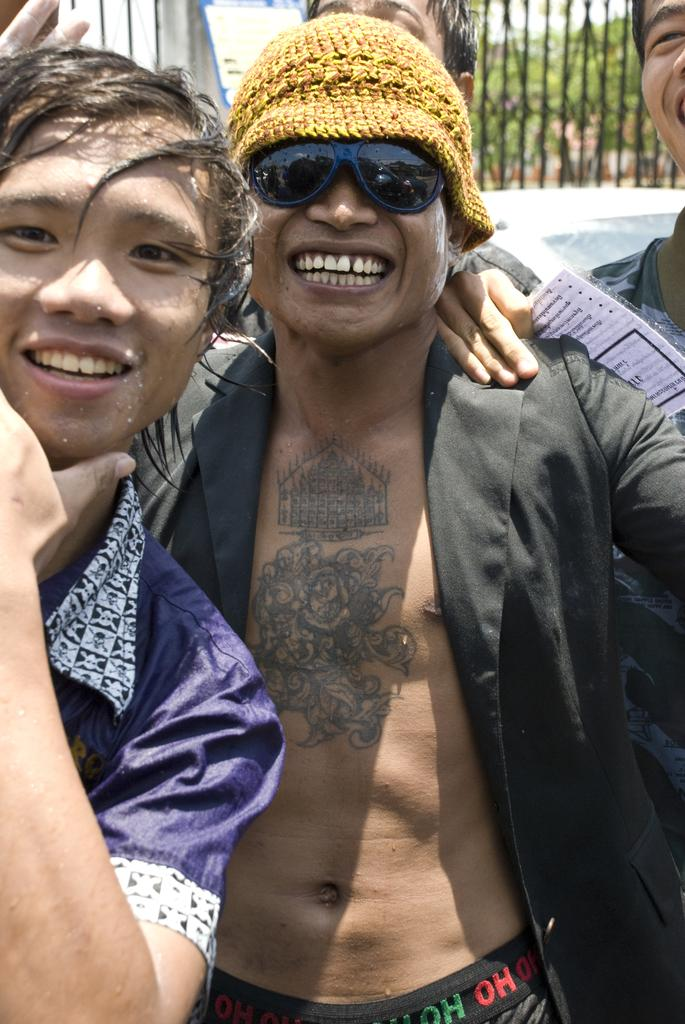What is happening in the image involving the people? There are people standing in the image, and two of them are smiling. Can you describe the background of the image? There is an iron grill in the background of the image. What type of cow can be seen grazing in the background of the image? There is no cow present in the image; it only features people standing and an iron grill in the background. How much butter is visible on the smiling faces of the people in the image? There is no butter visible on the faces of the people in the image. 